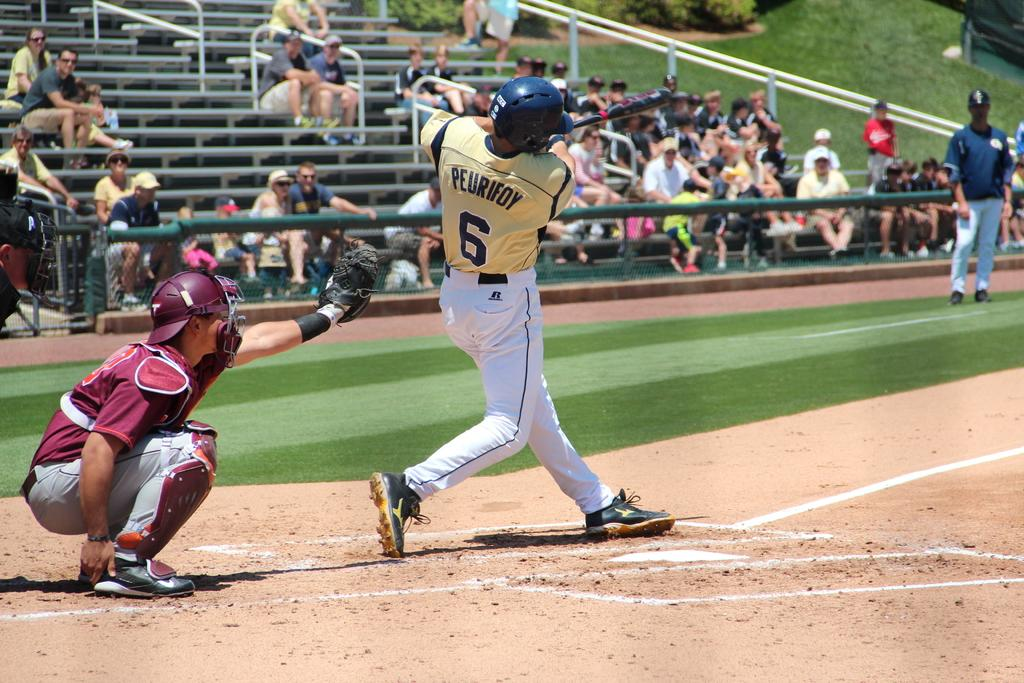Provide a one-sentence caption for the provided image. Baseball Game with the batters shirt saying Peurifoy 6. 